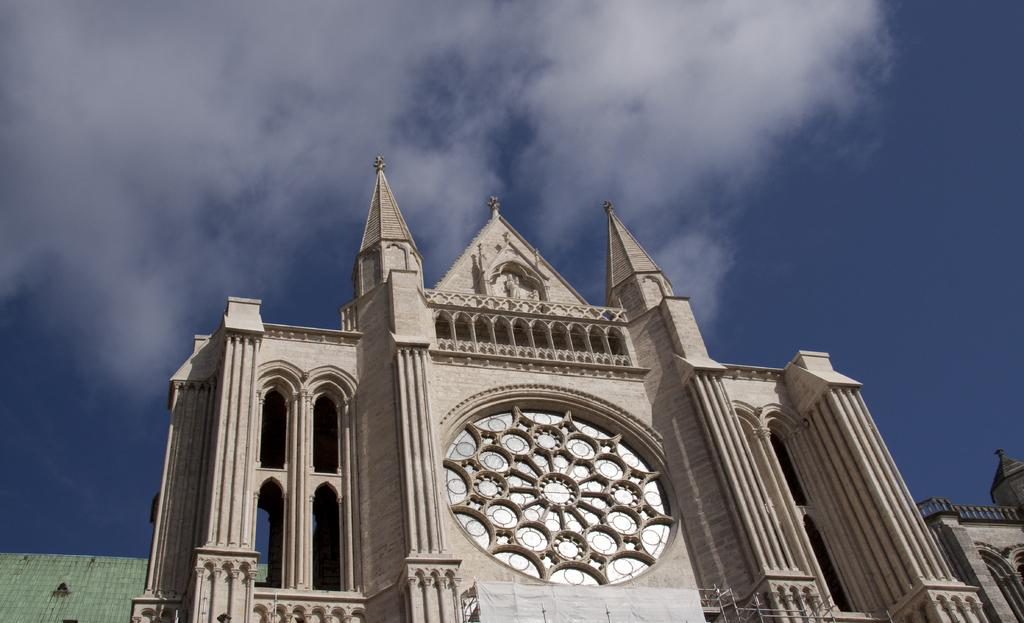What type of structure is visible in the image? There is a building in the image. What feature can be seen on the building? The building has a sculpture. What is the condition of the sky in the image? The sky is clear in the image. What type of rub can be seen on the sculpture in the image? There is no rub visible on the sculpture in the image. What feeling does the building evoke in the image? The image does not convey any specific feelings or emotions, so it cannot be determined from the image alone. 